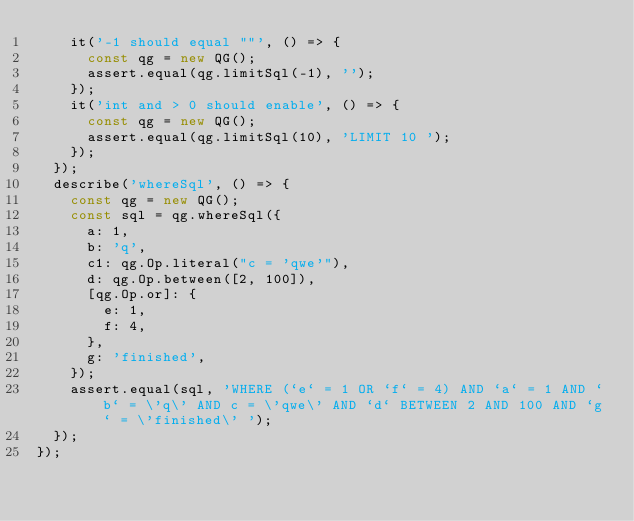Convert code to text. <code><loc_0><loc_0><loc_500><loc_500><_JavaScript_>    it('-1 should equal ""', () => {
      const qg = new QG();
      assert.equal(qg.limitSql(-1), '');
    });
    it('int and > 0 should enable', () => {
      const qg = new QG();
      assert.equal(qg.limitSql(10), 'LIMIT 10 ');
    });
  });
  describe('whereSql', () => {
    const qg = new QG();
    const sql = qg.whereSql({
      a: 1,
      b: 'q',
      c1: qg.Op.literal("c = 'qwe'"),
      d: qg.Op.between([2, 100]),
      [qg.Op.or]: {
        e: 1,
        f: 4,
      },
      g: 'finished',
    });
    assert.equal(sql, 'WHERE (`e` = 1 OR `f` = 4) AND `a` = 1 AND `b` = \'q\' AND c = \'qwe\' AND `d` BETWEEN 2 AND 100 AND `g` = \'finished\' ');
  });
});
</code> 